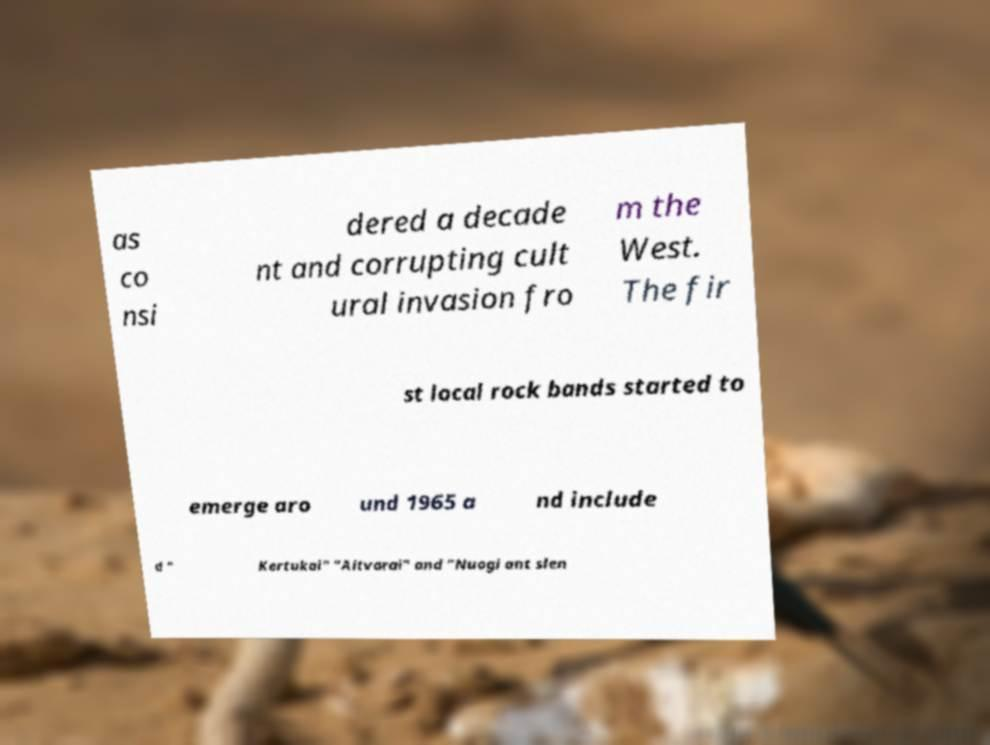Can you accurately transcribe the text from the provided image for me? as co nsi dered a decade nt and corrupting cult ural invasion fro m the West. The fir st local rock bands started to emerge aro und 1965 a nd include d " Kertukai" "Aitvarai" and "Nuogi ant slen 